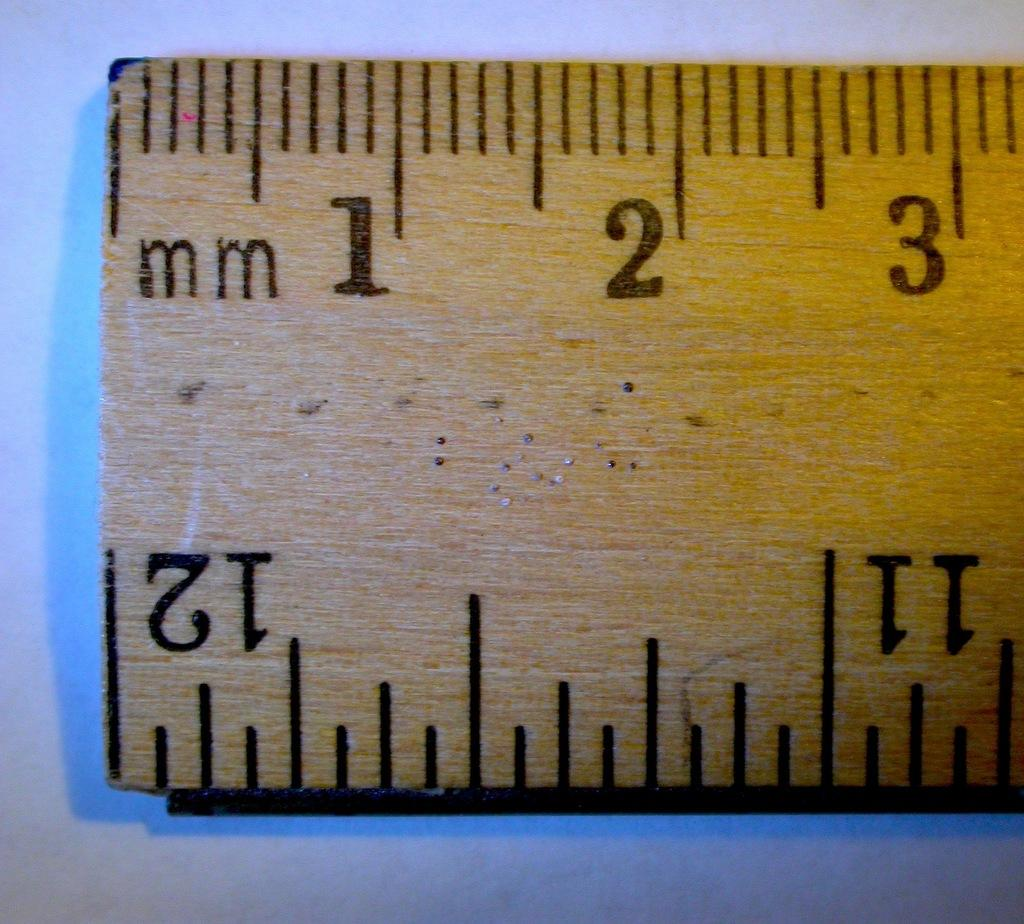<image>
Describe the image concisely. a ruler that has the numbers 1 2 and 3 on it 